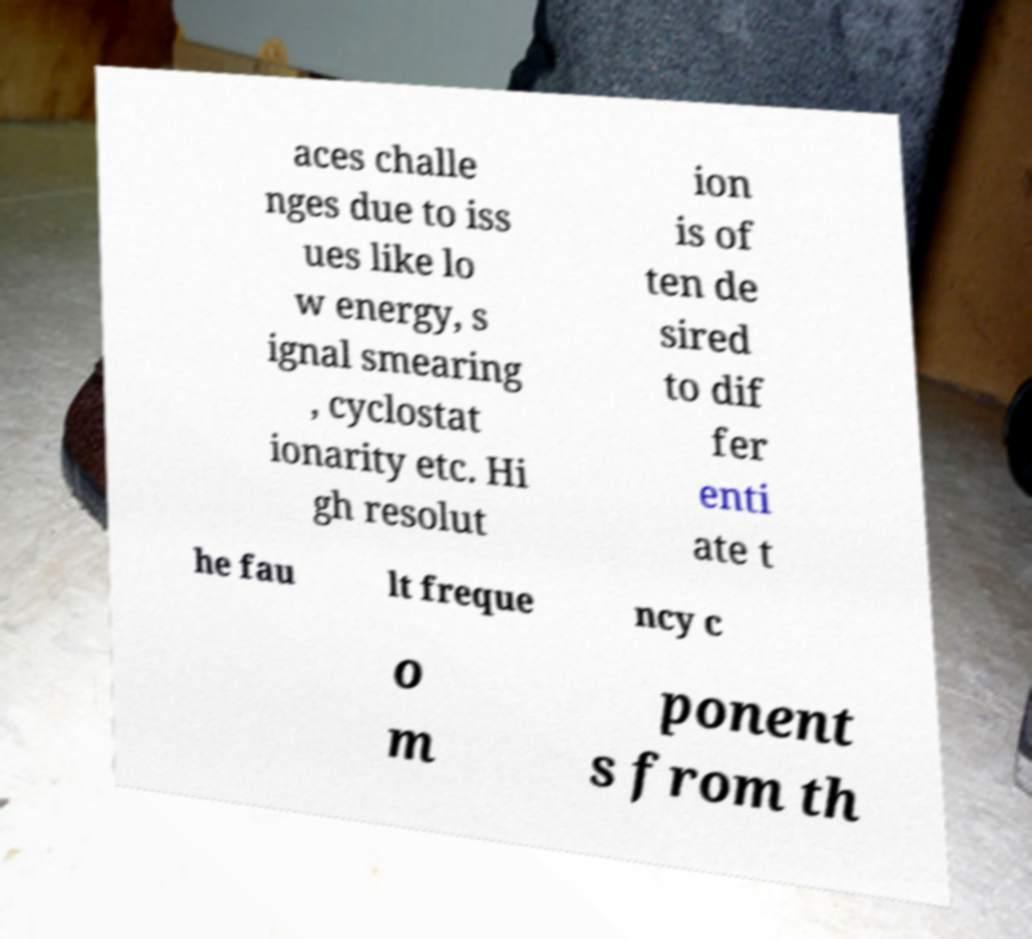What messages or text are displayed in this image? I need them in a readable, typed format. aces challe nges due to iss ues like lo w energy, s ignal smearing , cyclostat ionarity etc. Hi gh resolut ion is of ten de sired to dif fer enti ate t he fau lt freque ncy c o m ponent s from th 